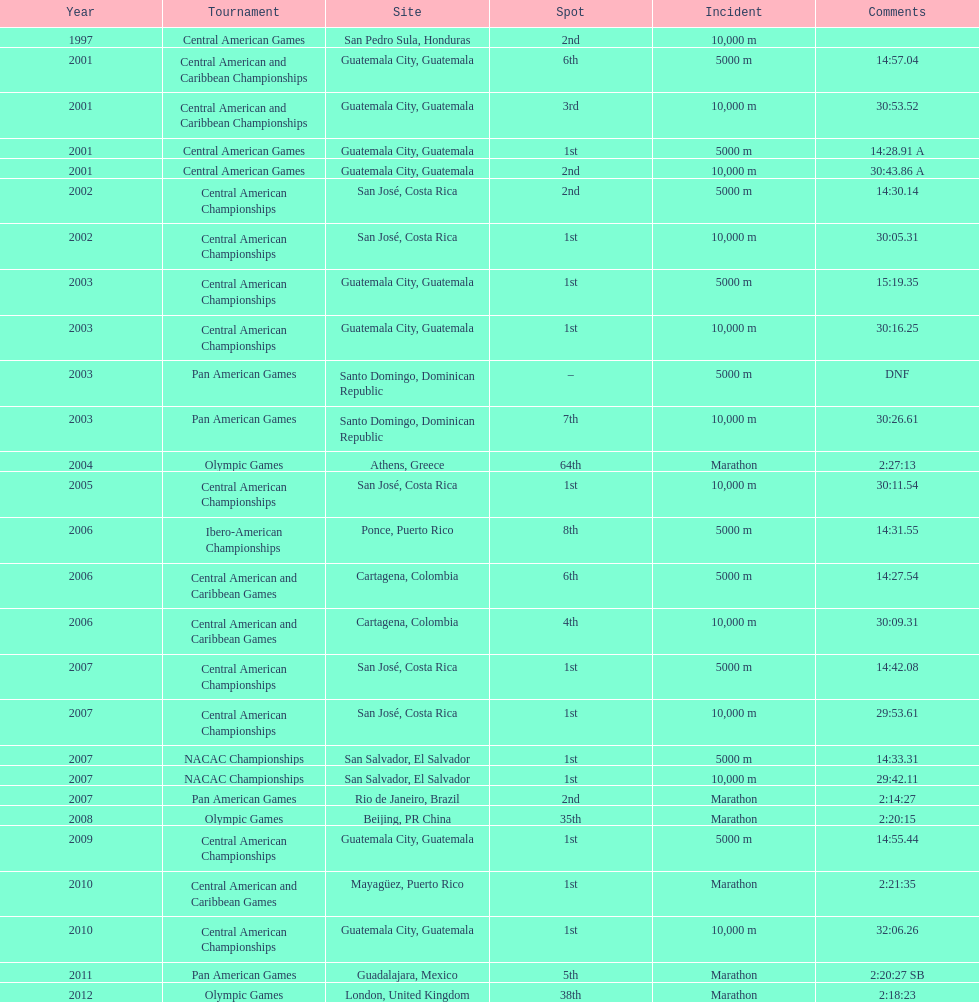Tell me the number of times they competed in guatamala. 5. Would you be able to parse every entry in this table? {'header': ['Year', 'Tournament', 'Site', 'Spot', 'Incident', 'Comments'], 'rows': [['1997', 'Central American Games', 'San Pedro Sula, Honduras', '2nd', '10,000 m', ''], ['2001', 'Central American and Caribbean Championships', 'Guatemala City, Guatemala', '6th', '5000 m', '14:57.04'], ['2001', 'Central American and Caribbean Championships', 'Guatemala City, Guatemala', '3rd', '10,000 m', '30:53.52'], ['2001', 'Central American Games', 'Guatemala City, Guatemala', '1st', '5000 m', '14:28.91 A'], ['2001', 'Central American Games', 'Guatemala City, Guatemala', '2nd', '10,000 m', '30:43.86 A'], ['2002', 'Central American Championships', 'San José, Costa Rica', '2nd', '5000 m', '14:30.14'], ['2002', 'Central American Championships', 'San José, Costa Rica', '1st', '10,000 m', '30:05.31'], ['2003', 'Central American Championships', 'Guatemala City, Guatemala', '1st', '5000 m', '15:19.35'], ['2003', 'Central American Championships', 'Guatemala City, Guatemala', '1st', '10,000 m', '30:16.25'], ['2003', 'Pan American Games', 'Santo Domingo, Dominican Republic', '–', '5000 m', 'DNF'], ['2003', 'Pan American Games', 'Santo Domingo, Dominican Republic', '7th', '10,000 m', '30:26.61'], ['2004', 'Olympic Games', 'Athens, Greece', '64th', 'Marathon', '2:27:13'], ['2005', 'Central American Championships', 'San José, Costa Rica', '1st', '10,000 m', '30:11.54'], ['2006', 'Ibero-American Championships', 'Ponce, Puerto Rico', '8th', '5000 m', '14:31.55'], ['2006', 'Central American and Caribbean Games', 'Cartagena, Colombia', '6th', '5000 m', '14:27.54'], ['2006', 'Central American and Caribbean Games', 'Cartagena, Colombia', '4th', '10,000 m', '30:09.31'], ['2007', 'Central American Championships', 'San José, Costa Rica', '1st', '5000 m', '14:42.08'], ['2007', 'Central American Championships', 'San José, Costa Rica', '1st', '10,000 m', '29:53.61'], ['2007', 'NACAC Championships', 'San Salvador, El Salvador', '1st', '5000 m', '14:33.31'], ['2007', 'NACAC Championships', 'San Salvador, El Salvador', '1st', '10,000 m', '29:42.11'], ['2007', 'Pan American Games', 'Rio de Janeiro, Brazil', '2nd', 'Marathon', '2:14:27'], ['2008', 'Olympic Games', 'Beijing, PR China', '35th', 'Marathon', '2:20:15'], ['2009', 'Central American Championships', 'Guatemala City, Guatemala', '1st', '5000 m', '14:55.44'], ['2010', 'Central American and Caribbean Games', 'Mayagüez, Puerto Rico', '1st', 'Marathon', '2:21:35'], ['2010', 'Central American Championships', 'Guatemala City, Guatemala', '1st', '10,000 m', '32:06.26'], ['2011', 'Pan American Games', 'Guadalajara, Mexico', '5th', 'Marathon', '2:20:27 SB'], ['2012', 'Olympic Games', 'London, United Kingdom', '38th', 'Marathon', '2:18:23']]} 